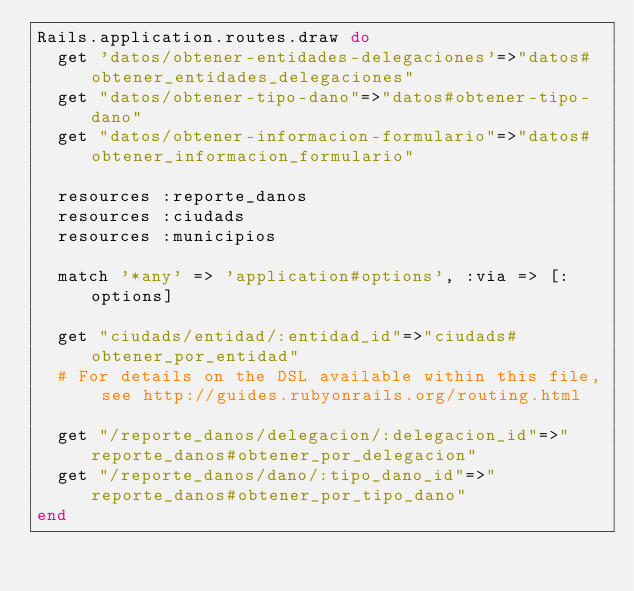<code> <loc_0><loc_0><loc_500><loc_500><_Ruby_>Rails.application.routes.draw do
  get 'datos/obtener-entidades-delegaciones'=>"datos#obtener_entidades_delegaciones"
  get "datos/obtener-tipo-dano"=>"datos#obtener-tipo-dano"
  get "datos/obtener-informacion-formulario"=>"datos#obtener_informacion_formulario"

  resources :reporte_danos
  resources :ciudads
  resources :municipios

  match '*any' => 'application#options', :via => [:options]

  get "ciudads/entidad/:entidad_id"=>"ciudads#obtener_por_entidad"
  # For details on the DSL available within this file, see http://guides.rubyonrails.org/routing.html

  get "/reporte_danos/delegacion/:delegacion_id"=>"reporte_danos#obtener_por_delegacion"
  get "/reporte_danos/dano/:tipo_dano_id"=>"reporte_danos#obtener_por_tipo_dano"
end
</code> 